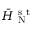Convert formula to latex. <formula><loc_0><loc_0><loc_500><loc_500>\ B a r { H } _ { N } ^ { s t }</formula> 